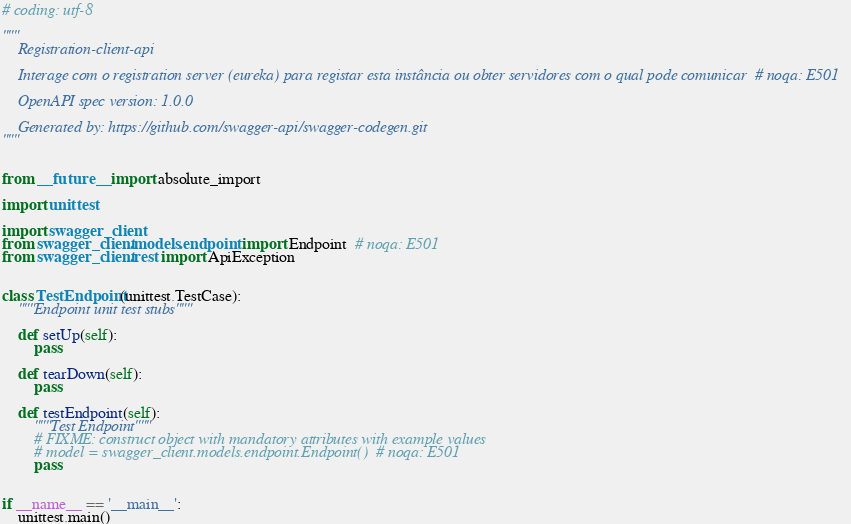Convert code to text. <code><loc_0><loc_0><loc_500><loc_500><_Python_># coding: utf-8

"""
    Registration-client-api

    Interage com o registration server (eureka) para registar esta instância ou obter servidores com o qual pode comunicar  # noqa: E501

    OpenAPI spec version: 1.0.0
    
    Generated by: https://github.com/swagger-api/swagger-codegen.git
"""


from __future__ import absolute_import

import unittest

import swagger_client
from swagger_client.models.endpoint import Endpoint  # noqa: E501
from swagger_client.rest import ApiException


class TestEndpoint(unittest.TestCase):
    """Endpoint unit test stubs"""

    def setUp(self):
        pass

    def tearDown(self):
        pass

    def testEndpoint(self):
        """Test Endpoint"""
        # FIXME: construct object with mandatory attributes with example values
        # model = swagger_client.models.endpoint.Endpoint()  # noqa: E501
        pass


if __name__ == '__main__':
    unittest.main()
</code> 